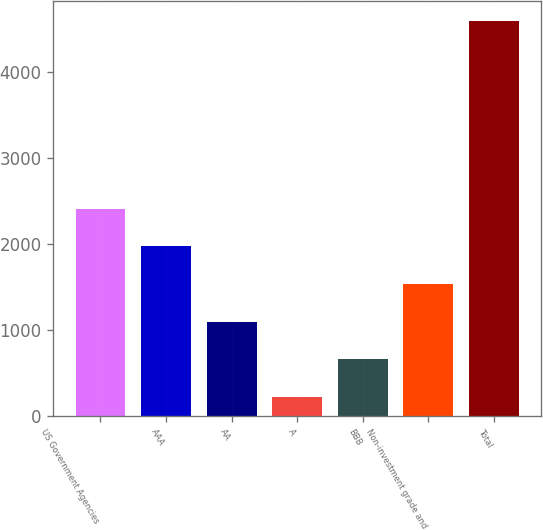Convert chart. <chart><loc_0><loc_0><loc_500><loc_500><bar_chart><fcel>US Government Agencies<fcel>AAA<fcel>AA<fcel>A<fcel>BBB<fcel>Non-investment grade and<fcel>Total<nl><fcel>2405.5<fcel>1967.8<fcel>1092.4<fcel>217<fcel>654.7<fcel>1530.1<fcel>4594<nl></chart> 